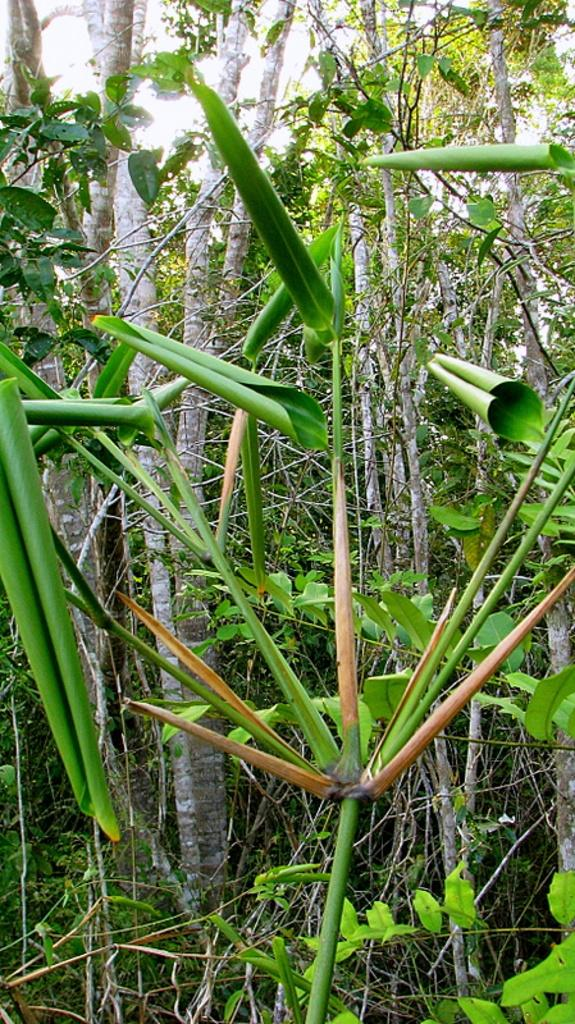What type of vegetation is present in the image? There are green trees in the image. What is the condition of the grass in the image? There is dry grass in the image. How many dinosaurs can be seen grazing on the quince in the image? There are no dinosaurs or quince present in the image. What is the height of the cent in the image? There is no cent present in the image. 